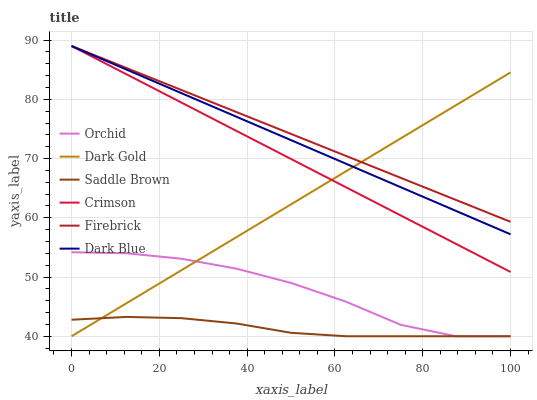Does Saddle Brown have the minimum area under the curve?
Answer yes or no. Yes. Does Firebrick have the maximum area under the curve?
Answer yes or no. Yes. Does Dark Blue have the minimum area under the curve?
Answer yes or no. No. Does Dark Blue have the maximum area under the curve?
Answer yes or no. No. Is Dark Gold the smoothest?
Answer yes or no. Yes. Is Orchid the roughest?
Answer yes or no. Yes. Is Firebrick the smoothest?
Answer yes or no. No. Is Firebrick the roughest?
Answer yes or no. No. Does Dark Gold have the lowest value?
Answer yes or no. Yes. Does Dark Blue have the lowest value?
Answer yes or no. No. Does Crimson have the highest value?
Answer yes or no. Yes. Does Saddle Brown have the highest value?
Answer yes or no. No. Is Orchid less than Dark Blue?
Answer yes or no. Yes. Is Firebrick greater than Saddle Brown?
Answer yes or no. Yes. Does Firebrick intersect Dark Blue?
Answer yes or no. Yes. Is Firebrick less than Dark Blue?
Answer yes or no. No. Is Firebrick greater than Dark Blue?
Answer yes or no. No. Does Orchid intersect Dark Blue?
Answer yes or no. No. 